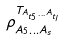Convert formula to latex. <formula><loc_0><loc_0><loc_500><loc_500>\rho _ { A _ { 5 } \dots A _ { s } } ^ { T _ { A _ { t _ { 5 } } \dots A _ { t _ { l } } } }</formula> 